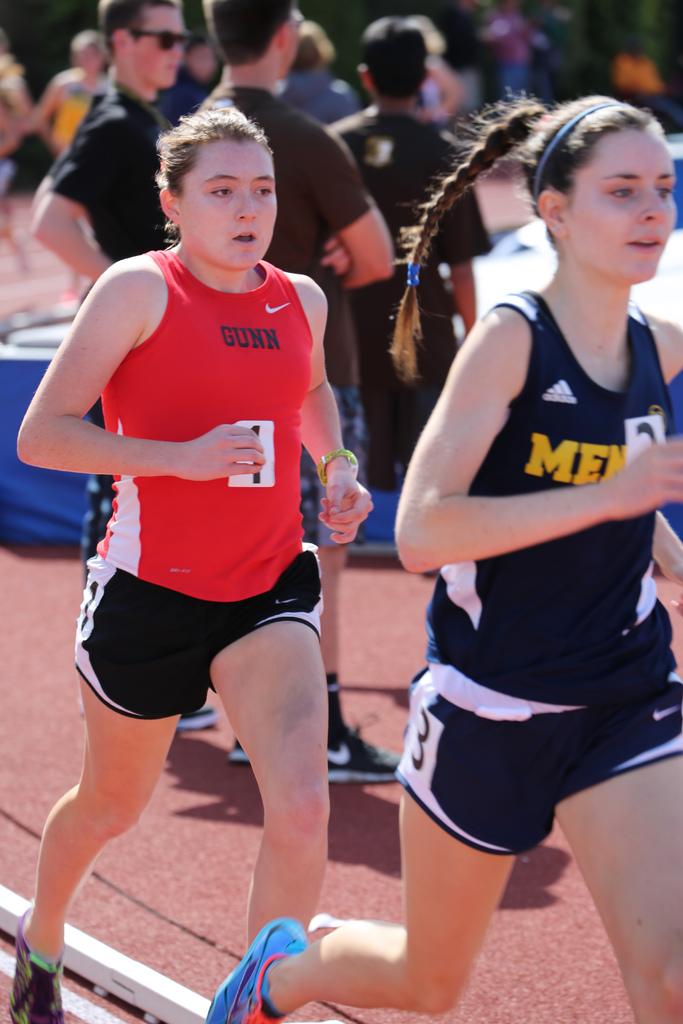What color is the shirt of the person in 2nd place?
Provide a succinct answer. Answering does not require reading text in the image. Who does the girl in red run for?
Offer a terse response. Gunn. 